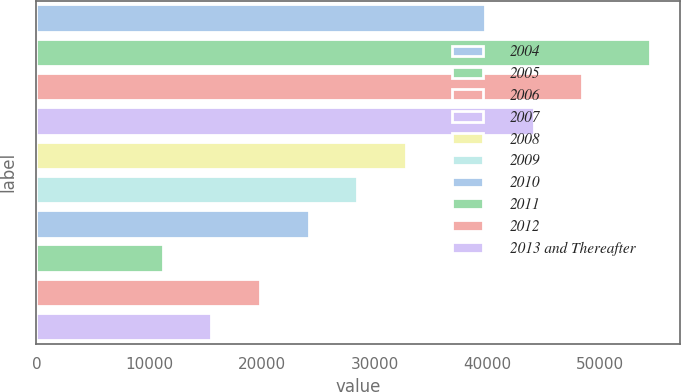<chart> <loc_0><loc_0><loc_500><loc_500><bar_chart><fcel>2004<fcel>2005<fcel>2006<fcel>2007<fcel>2008<fcel>2009<fcel>2010<fcel>2011<fcel>2012<fcel>2013 and Thereafter<nl><fcel>39784<fcel>54391<fcel>48423.6<fcel>44103.8<fcel>32792<fcel>28472.2<fcel>24152.4<fcel>11193<fcel>19832.6<fcel>15512.8<nl></chart> 